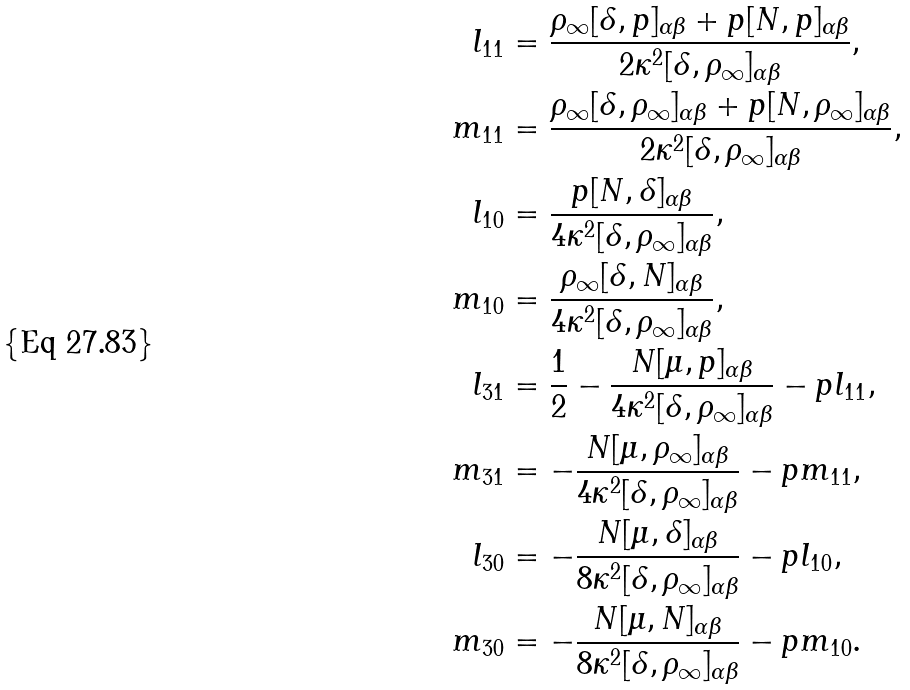<formula> <loc_0><loc_0><loc_500><loc_500>l _ { 1 1 } & = \frac { \rho _ { \infty } [ \delta , p ] _ { \alpha \beta } + p [ N , p ] _ { \alpha \beta } } { 2 \kappa ^ { 2 } [ \delta , \rho _ { \infty } ] _ { \alpha \beta } } , \\ m _ { 1 1 } & = \frac { \rho _ { \infty } [ \delta , \rho _ { \infty } ] _ { \alpha \beta } + p [ N , \rho _ { \infty } ] _ { \alpha \beta } } { 2 \kappa ^ { 2 } [ \delta , \rho _ { \infty } ] _ { \alpha \beta } } , \\ l _ { 1 0 } & = \frac { p [ N , \delta ] _ { \alpha \beta } } { 4 \kappa ^ { 2 } [ \delta , \rho _ { \infty } ] _ { \alpha \beta } } , \\ m _ { 1 0 } & = \frac { \rho _ { \infty } [ \delta , N ] _ { \alpha \beta } } { 4 \kappa ^ { 2 } [ \delta , \rho _ { \infty } ] _ { \alpha \beta } } , \\ l _ { 3 1 } & = \frac { 1 } { 2 } - \frac { N [ \mu , p ] _ { \alpha \beta } } { 4 \kappa ^ { 2 } [ \delta , \rho _ { \infty } ] _ { \alpha \beta } } - p l _ { 1 1 } , \\ m _ { 3 1 } & = - \frac { N [ \mu , \rho _ { \infty } ] _ { \alpha \beta } } { 4 \kappa ^ { 2 } [ \delta , \rho _ { \infty } ] _ { \alpha \beta } } - p m _ { 1 1 } , \\ l _ { 3 0 } & = - \frac { N [ \mu , \delta ] _ { \alpha \beta } } { 8 \kappa ^ { 2 } [ \delta , \rho _ { \infty } ] _ { \alpha \beta } } - p l _ { 1 0 } , \\ m _ { 3 0 } & = - \frac { N [ \mu , N ] _ { \alpha \beta } } { 8 \kappa ^ { 2 } [ \delta , \rho _ { \infty } ] _ { \alpha \beta } } - p m _ { 1 0 } .</formula> 